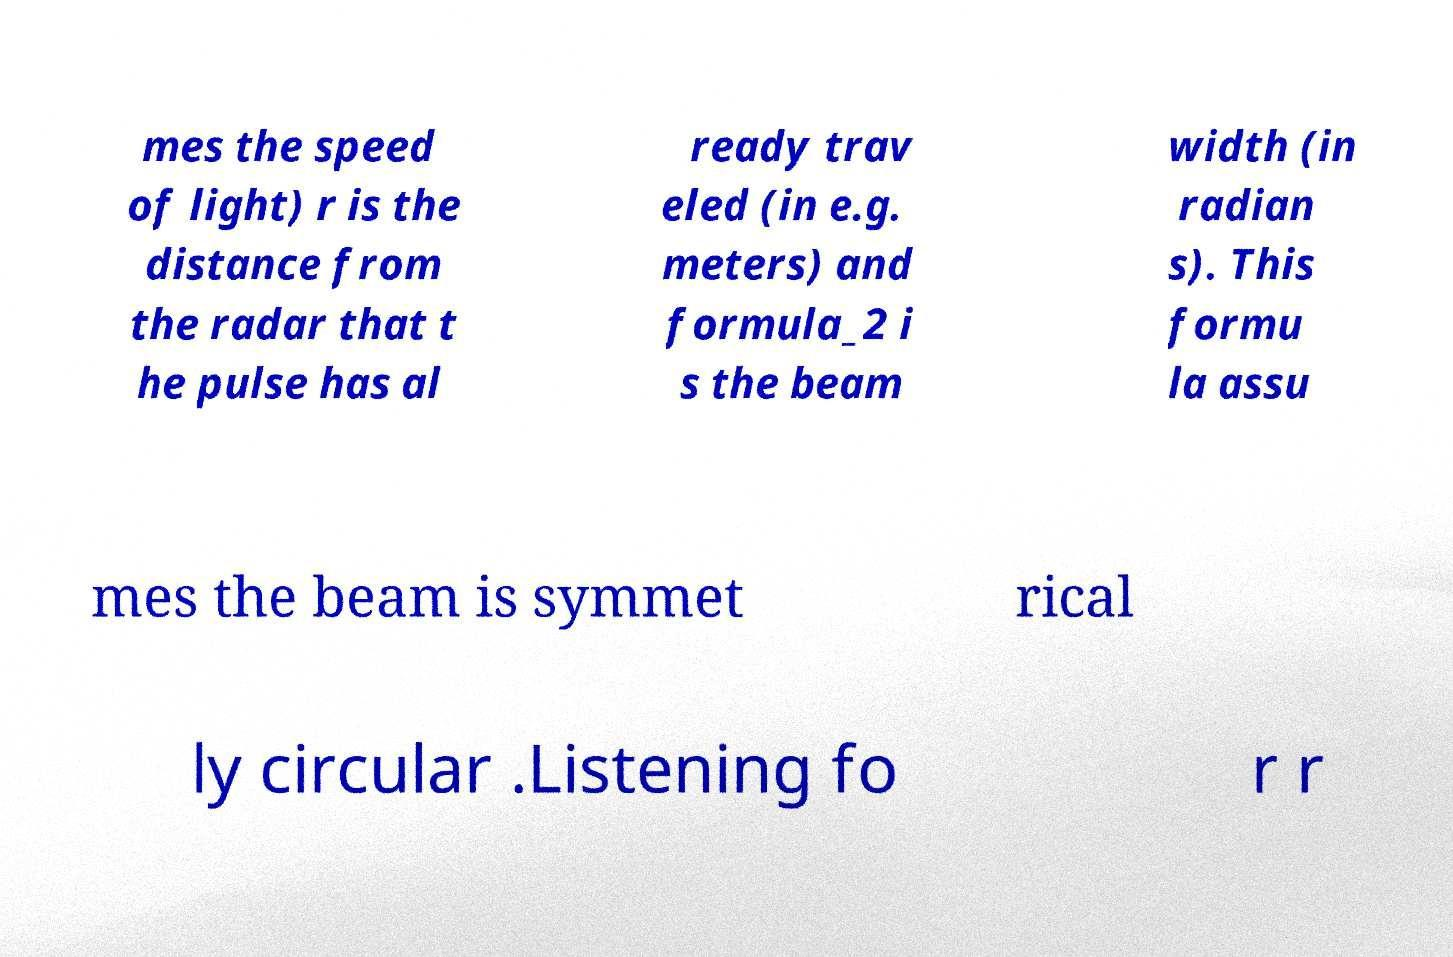I need the written content from this picture converted into text. Can you do that? mes the speed of light) r is the distance from the radar that t he pulse has al ready trav eled (in e.g. meters) and formula_2 i s the beam width (in radian s). This formu la assu mes the beam is symmet rical ly circular .Listening fo r r 